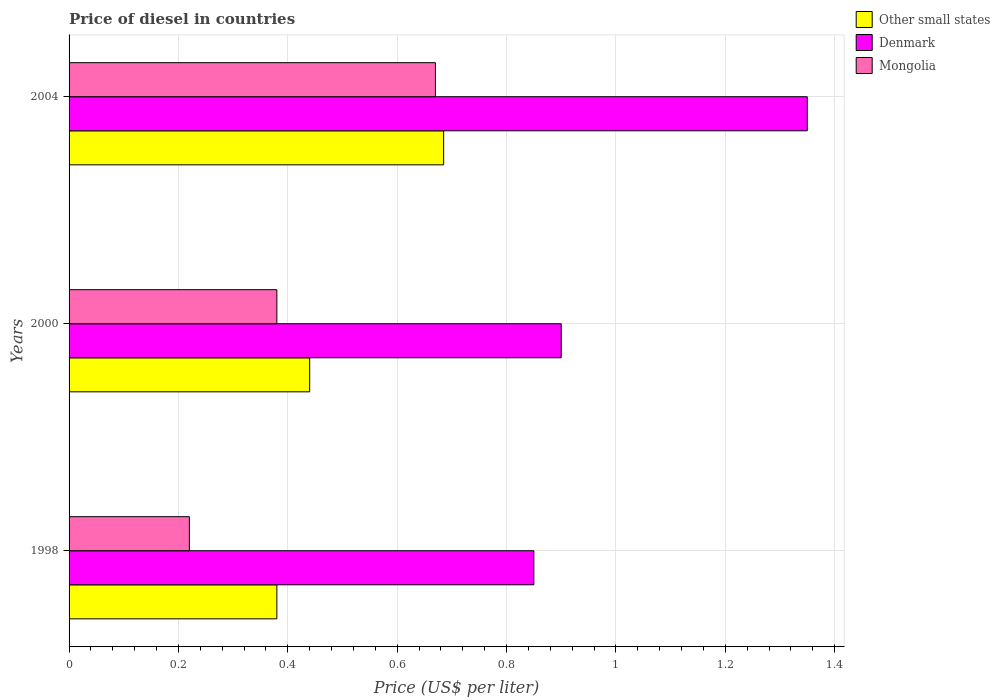Are the number of bars per tick equal to the number of legend labels?
Keep it short and to the point. Yes. Are the number of bars on each tick of the Y-axis equal?
Ensure brevity in your answer.  Yes. How many bars are there on the 2nd tick from the top?
Your answer should be compact. 3. What is the label of the 1st group of bars from the top?
Your response must be concise. 2004. Across all years, what is the maximum price of diesel in Denmark?
Offer a terse response. 1.35. Across all years, what is the minimum price of diesel in Denmark?
Give a very brief answer. 0.85. What is the total price of diesel in Other small states in the graph?
Keep it short and to the point. 1.51. What is the difference between the price of diesel in Denmark in 1998 and that in 2004?
Your answer should be very brief. -0.5. What is the difference between the price of diesel in Denmark in 2004 and the price of diesel in Mongolia in 1998?
Provide a short and direct response. 1.13. What is the average price of diesel in Denmark per year?
Ensure brevity in your answer.  1.03. In the year 2004, what is the difference between the price of diesel in Mongolia and price of diesel in Denmark?
Make the answer very short. -0.68. What is the ratio of the price of diesel in Mongolia in 1998 to that in 2000?
Offer a terse response. 0.58. What is the difference between the highest and the second highest price of diesel in Denmark?
Make the answer very short. 0.45. What is the difference between the highest and the lowest price of diesel in Other small states?
Your answer should be very brief. 0.31. In how many years, is the price of diesel in Denmark greater than the average price of diesel in Denmark taken over all years?
Provide a short and direct response. 1. Is the sum of the price of diesel in Other small states in 1998 and 2000 greater than the maximum price of diesel in Mongolia across all years?
Your answer should be compact. Yes. What does the 3rd bar from the bottom in 1998 represents?
Ensure brevity in your answer.  Mongolia. Is it the case that in every year, the sum of the price of diesel in Other small states and price of diesel in Mongolia is greater than the price of diesel in Denmark?
Make the answer very short. No. Are all the bars in the graph horizontal?
Your answer should be compact. Yes. How many years are there in the graph?
Provide a succinct answer. 3. What is the difference between two consecutive major ticks on the X-axis?
Your response must be concise. 0.2. Are the values on the major ticks of X-axis written in scientific E-notation?
Your answer should be very brief. No. Does the graph contain any zero values?
Provide a succinct answer. No. Does the graph contain grids?
Your response must be concise. Yes. How are the legend labels stacked?
Offer a terse response. Vertical. What is the title of the graph?
Keep it short and to the point. Price of diesel in countries. Does "Japan" appear as one of the legend labels in the graph?
Ensure brevity in your answer.  No. What is the label or title of the X-axis?
Ensure brevity in your answer.  Price (US$ per liter). What is the label or title of the Y-axis?
Provide a short and direct response. Years. What is the Price (US$ per liter) of Other small states in 1998?
Your answer should be compact. 0.38. What is the Price (US$ per liter) of Mongolia in 1998?
Make the answer very short. 0.22. What is the Price (US$ per liter) of Other small states in 2000?
Offer a very short reply. 0.44. What is the Price (US$ per liter) in Mongolia in 2000?
Offer a very short reply. 0.38. What is the Price (US$ per liter) of Other small states in 2004?
Keep it short and to the point. 0.69. What is the Price (US$ per liter) in Denmark in 2004?
Your answer should be very brief. 1.35. What is the Price (US$ per liter) in Mongolia in 2004?
Make the answer very short. 0.67. Across all years, what is the maximum Price (US$ per liter) of Other small states?
Your answer should be compact. 0.69. Across all years, what is the maximum Price (US$ per liter) of Denmark?
Your answer should be very brief. 1.35. Across all years, what is the maximum Price (US$ per liter) in Mongolia?
Ensure brevity in your answer.  0.67. Across all years, what is the minimum Price (US$ per liter) of Other small states?
Provide a succinct answer. 0.38. Across all years, what is the minimum Price (US$ per liter) of Denmark?
Your response must be concise. 0.85. Across all years, what is the minimum Price (US$ per liter) in Mongolia?
Give a very brief answer. 0.22. What is the total Price (US$ per liter) in Other small states in the graph?
Your response must be concise. 1.5. What is the total Price (US$ per liter) of Denmark in the graph?
Offer a very short reply. 3.1. What is the total Price (US$ per liter) in Mongolia in the graph?
Make the answer very short. 1.27. What is the difference between the Price (US$ per liter) in Other small states in 1998 and that in 2000?
Your answer should be compact. -0.06. What is the difference between the Price (US$ per liter) of Mongolia in 1998 and that in 2000?
Your response must be concise. -0.16. What is the difference between the Price (US$ per liter) in Other small states in 1998 and that in 2004?
Provide a succinct answer. -0.3. What is the difference between the Price (US$ per liter) in Mongolia in 1998 and that in 2004?
Keep it short and to the point. -0.45. What is the difference between the Price (US$ per liter) of Other small states in 2000 and that in 2004?
Your answer should be compact. -0.24. What is the difference between the Price (US$ per liter) of Denmark in 2000 and that in 2004?
Provide a short and direct response. -0.45. What is the difference between the Price (US$ per liter) in Mongolia in 2000 and that in 2004?
Your response must be concise. -0.29. What is the difference between the Price (US$ per liter) of Other small states in 1998 and the Price (US$ per liter) of Denmark in 2000?
Provide a short and direct response. -0.52. What is the difference between the Price (US$ per liter) in Other small states in 1998 and the Price (US$ per liter) in Mongolia in 2000?
Your response must be concise. 0. What is the difference between the Price (US$ per liter) in Denmark in 1998 and the Price (US$ per liter) in Mongolia in 2000?
Provide a succinct answer. 0.47. What is the difference between the Price (US$ per liter) in Other small states in 1998 and the Price (US$ per liter) in Denmark in 2004?
Make the answer very short. -0.97. What is the difference between the Price (US$ per liter) of Other small states in 1998 and the Price (US$ per liter) of Mongolia in 2004?
Give a very brief answer. -0.29. What is the difference between the Price (US$ per liter) of Denmark in 1998 and the Price (US$ per liter) of Mongolia in 2004?
Your answer should be compact. 0.18. What is the difference between the Price (US$ per liter) of Other small states in 2000 and the Price (US$ per liter) of Denmark in 2004?
Your answer should be compact. -0.91. What is the difference between the Price (US$ per liter) in Other small states in 2000 and the Price (US$ per liter) in Mongolia in 2004?
Provide a short and direct response. -0.23. What is the difference between the Price (US$ per liter) of Denmark in 2000 and the Price (US$ per liter) of Mongolia in 2004?
Your answer should be very brief. 0.23. What is the average Price (US$ per liter) of Other small states per year?
Keep it short and to the point. 0.5. What is the average Price (US$ per liter) in Denmark per year?
Offer a terse response. 1.03. What is the average Price (US$ per liter) in Mongolia per year?
Offer a very short reply. 0.42. In the year 1998, what is the difference between the Price (US$ per liter) in Other small states and Price (US$ per liter) in Denmark?
Offer a very short reply. -0.47. In the year 1998, what is the difference between the Price (US$ per liter) in Other small states and Price (US$ per liter) in Mongolia?
Your response must be concise. 0.16. In the year 1998, what is the difference between the Price (US$ per liter) of Denmark and Price (US$ per liter) of Mongolia?
Keep it short and to the point. 0.63. In the year 2000, what is the difference between the Price (US$ per liter) of Other small states and Price (US$ per liter) of Denmark?
Give a very brief answer. -0.46. In the year 2000, what is the difference between the Price (US$ per liter) of Denmark and Price (US$ per liter) of Mongolia?
Keep it short and to the point. 0.52. In the year 2004, what is the difference between the Price (US$ per liter) in Other small states and Price (US$ per liter) in Denmark?
Give a very brief answer. -0.67. In the year 2004, what is the difference between the Price (US$ per liter) of Other small states and Price (US$ per liter) of Mongolia?
Your answer should be compact. 0.01. In the year 2004, what is the difference between the Price (US$ per liter) in Denmark and Price (US$ per liter) in Mongolia?
Your answer should be compact. 0.68. What is the ratio of the Price (US$ per liter) in Other small states in 1998 to that in 2000?
Keep it short and to the point. 0.86. What is the ratio of the Price (US$ per liter) of Mongolia in 1998 to that in 2000?
Give a very brief answer. 0.58. What is the ratio of the Price (US$ per liter) in Other small states in 1998 to that in 2004?
Ensure brevity in your answer.  0.55. What is the ratio of the Price (US$ per liter) of Denmark in 1998 to that in 2004?
Offer a very short reply. 0.63. What is the ratio of the Price (US$ per liter) in Mongolia in 1998 to that in 2004?
Your answer should be compact. 0.33. What is the ratio of the Price (US$ per liter) in Other small states in 2000 to that in 2004?
Give a very brief answer. 0.64. What is the ratio of the Price (US$ per liter) in Denmark in 2000 to that in 2004?
Offer a very short reply. 0.67. What is the ratio of the Price (US$ per liter) in Mongolia in 2000 to that in 2004?
Offer a terse response. 0.57. What is the difference between the highest and the second highest Price (US$ per liter) of Other small states?
Your response must be concise. 0.24. What is the difference between the highest and the second highest Price (US$ per liter) of Denmark?
Ensure brevity in your answer.  0.45. What is the difference between the highest and the second highest Price (US$ per liter) of Mongolia?
Offer a terse response. 0.29. What is the difference between the highest and the lowest Price (US$ per liter) in Other small states?
Your answer should be compact. 0.3. What is the difference between the highest and the lowest Price (US$ per liter) of Mongolia?
Give a very brief answer. 0.45. 